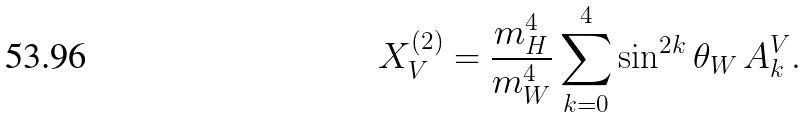<formula> <loc_0><loc_0><loc_500><loc_500>X _ { V } ^ { ( 2 ) } = \frac { m _ { H } ^ { 4 } } { m _ { W } ^ { 4 } } \sum _ { k = 0 } ^ { 4 } \sin ^ { 2 k } \theta _ { W } \, A _ { k } ^ { V } .</formula> 